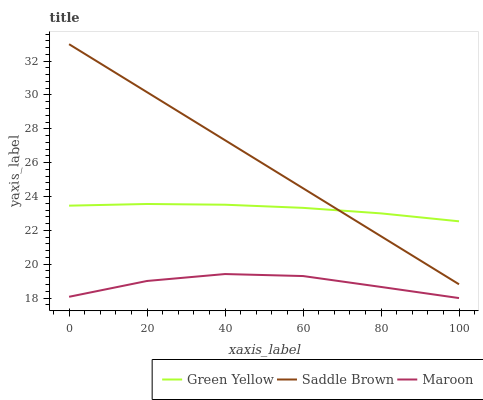Does Saddle Brown have the minimum area under the curve?
Answer yes or no. No. Does Maroon have the maximum area under the curve?
Answer yes or no. No. Is Maroon the smoothest?
Answer yes or no. No. Is Saddle Brown the roughest?
Answer yes or no. No. Does Saddle Brown have the lowest value?
Answer yes or no. No. Does Maroon have the highest value?
Answer yes or no. No. Is Maroon less than Green Yellow?
Answer yes or no. Yes. Is Green Yellow greater than Maroon?
Answer yes or no. Yes. Does Maroon intersect Green Yellow?
Answer yes or no. No. 